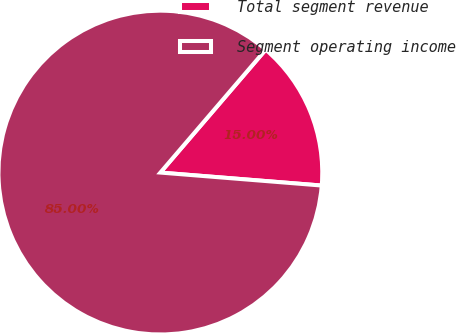Convert chart. <chart><loc_0><loc_0><loc_500><loc_500><pie_chart><fcel>Total segment revenue<fcel>Segment operating income<nl><fcel>15.0%<fcel>85.0%<nl></chart> 